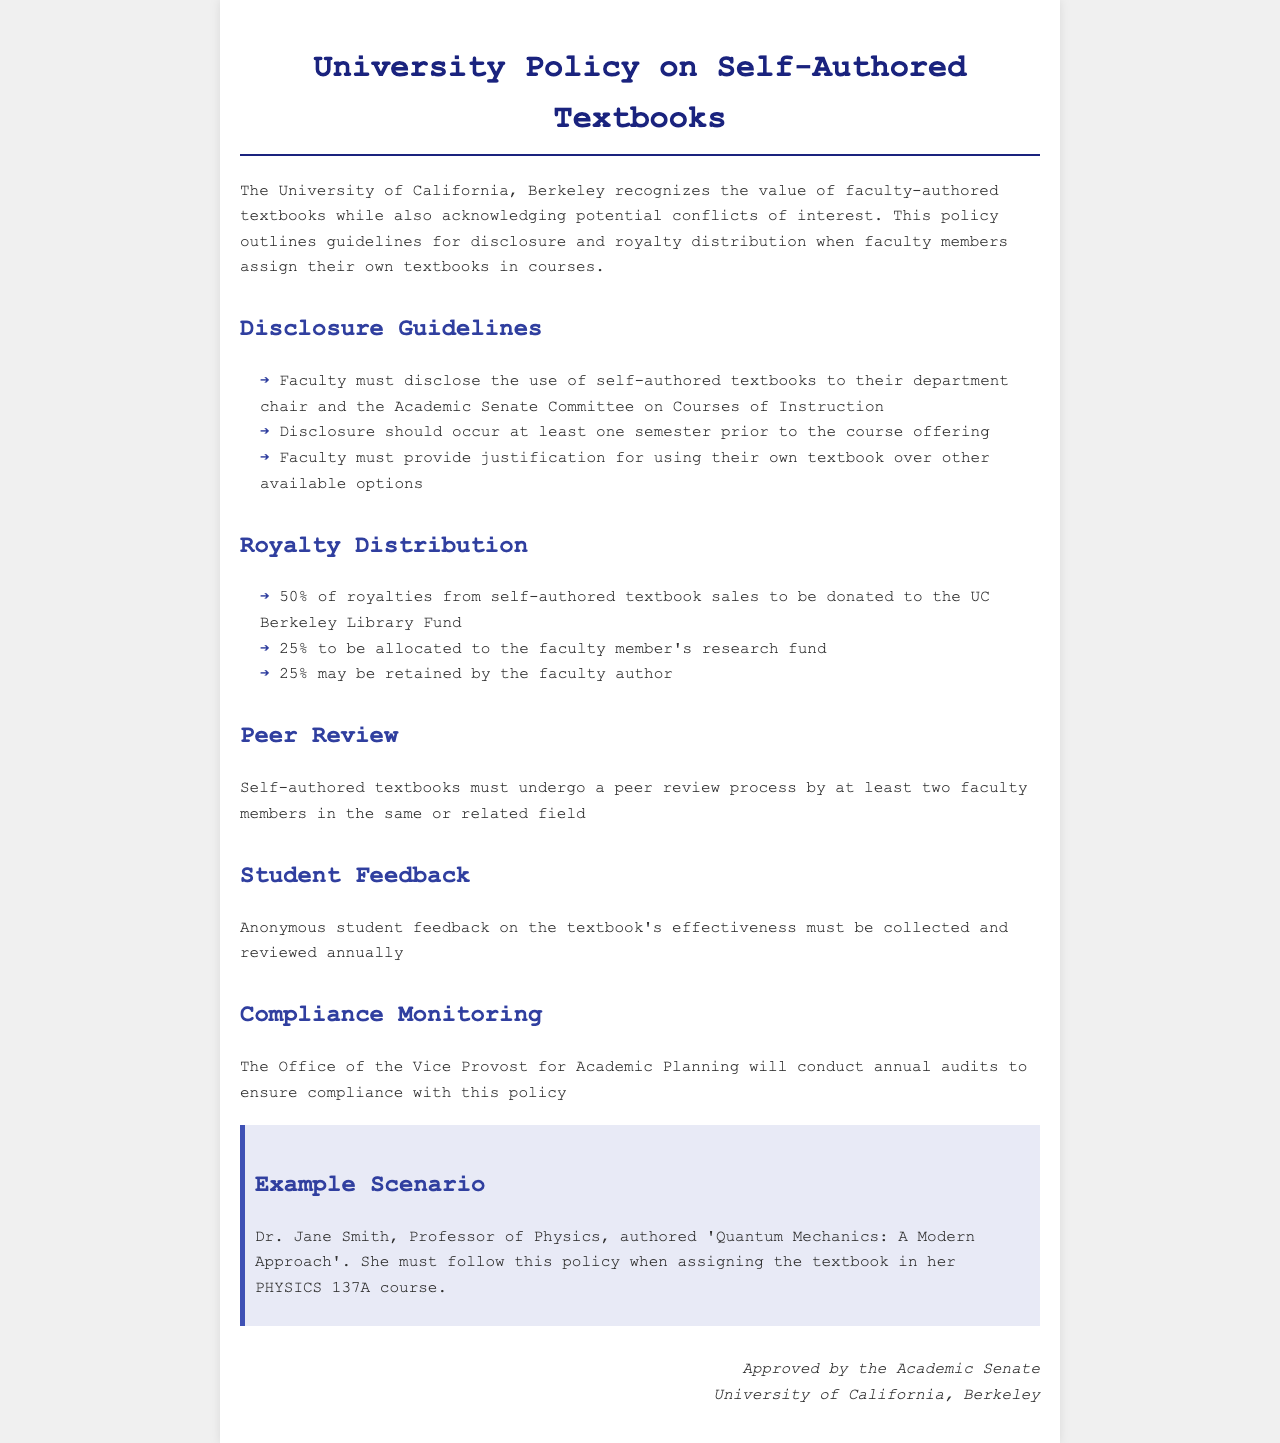What must faculty disclose when using their own textbooks? Faculty must disclose the use of self-authored textbooks to their department chair and the Academic Senate Committee on Courses of Instruction.
Answer: disclosure to department chair and Academic Senate Committee How much of the royalties is allocated to the faculty member's research fund? According to the document, 25% of royalties is allocated to the faculty member's research fund.
Answer: 25% What is the percentage of royalties donated to the UC Berkeley Library Fund? The document states that 50% of royalties from self-authored textbook sales are to be donated to the UC Berkeley Library Fund.
Answer: 50% How many faculty members must review a self-authored textbook? The policy specifies that self-authored textbooks must undergo a peer review process by at least two faculty members.
Answer: two What type of feedback must be collected from students regarding the textbooks? The document indicates that anonymous student feedback on the textbook's effectiveness must be collected and reviewed annually.
Answer: anonymous student feedback Who conducts annual audits to ensure compliance with this policy? The document states that the Office of the Vice Provost for Academic Planning will conduct annual audits to ensure compliance.
Answer: Office of the Vice Provost for Academic Planning What is the required notice period for faculty before the course offering when disclosing the use of their own textbook? Faculty must disclose at least one semester prior to the course offering.
Answer: one semester What is the title of the example scenario textbook authored by Dr. Jane Smith? In the example scenario, Dr. Jane Smith authored 'Quantum Mechanics: A Modern Approach'.
Answer: Quantum Mechanics: A Modern Approach 